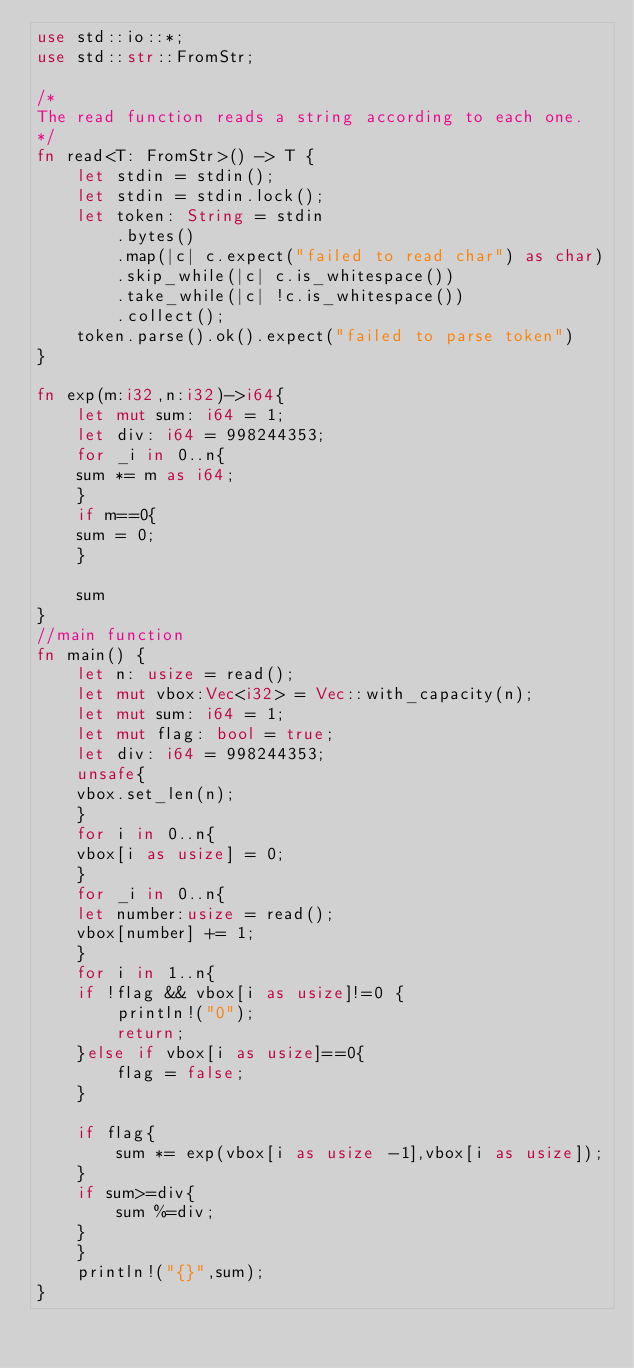Convert code to text. <code><loc_0><loc_0><loc_500><loc_500><_Rust_>use std::io::*;
use std::str::FromStr;

/* 
The read function reads a string according to each one. 
*/
fn read<T: FromStr>() -> T {
    let stdin = stdin();
    let stdin = stdin.lock();
    let token: String = stdin
        .bytes()
        .map(|c| c.expect("failed to read char") as char) 
        .skip_while(|c| c.is_whitespace())
        .take_while(|c| !c.is_whitespace())
        .collect();
    token.parse().ok().expect("failed to parse token")
}

fn exp(m:i32,n:i32)->i64{
    let mut sum: i64 = 1;
    let div: i64 = 998244353;
    for _i in 0..n{
	sum *= m as i64;
    }
    if m==0{
	sum = 0;
    }

    sum
}
//main function
fn main() {
    let n: usize = read();
    let mut vbox:Vec<i32> = Vec::with_capacity(n);
    let mut sum: i64 = 1;
    let mut flag: bool = true;
    let div: i64 = 998244353;
    unsafe{
	vbox.set_len(n);
    }
    for i in 0..n{
	vbox[i as usize] = 0;
    }
    for _i in 0..n{
	let number:usize = read();
	vbox[number] += 1;
    }
    for i in 1..n{
	if !flag && vbox[i as usize]!=0 {
	    println!("0");
	    return;
	}else if vbox[i as usize]==0{
	    flag = false;
	}
	
	if flag{
	    sum *= exp(vbox[i as usize -1],vbox[i as usize]);
	}
	if sum>=div{
	    sum %=div;
	}
    }
    println!("{}",sum);
}
</code> 